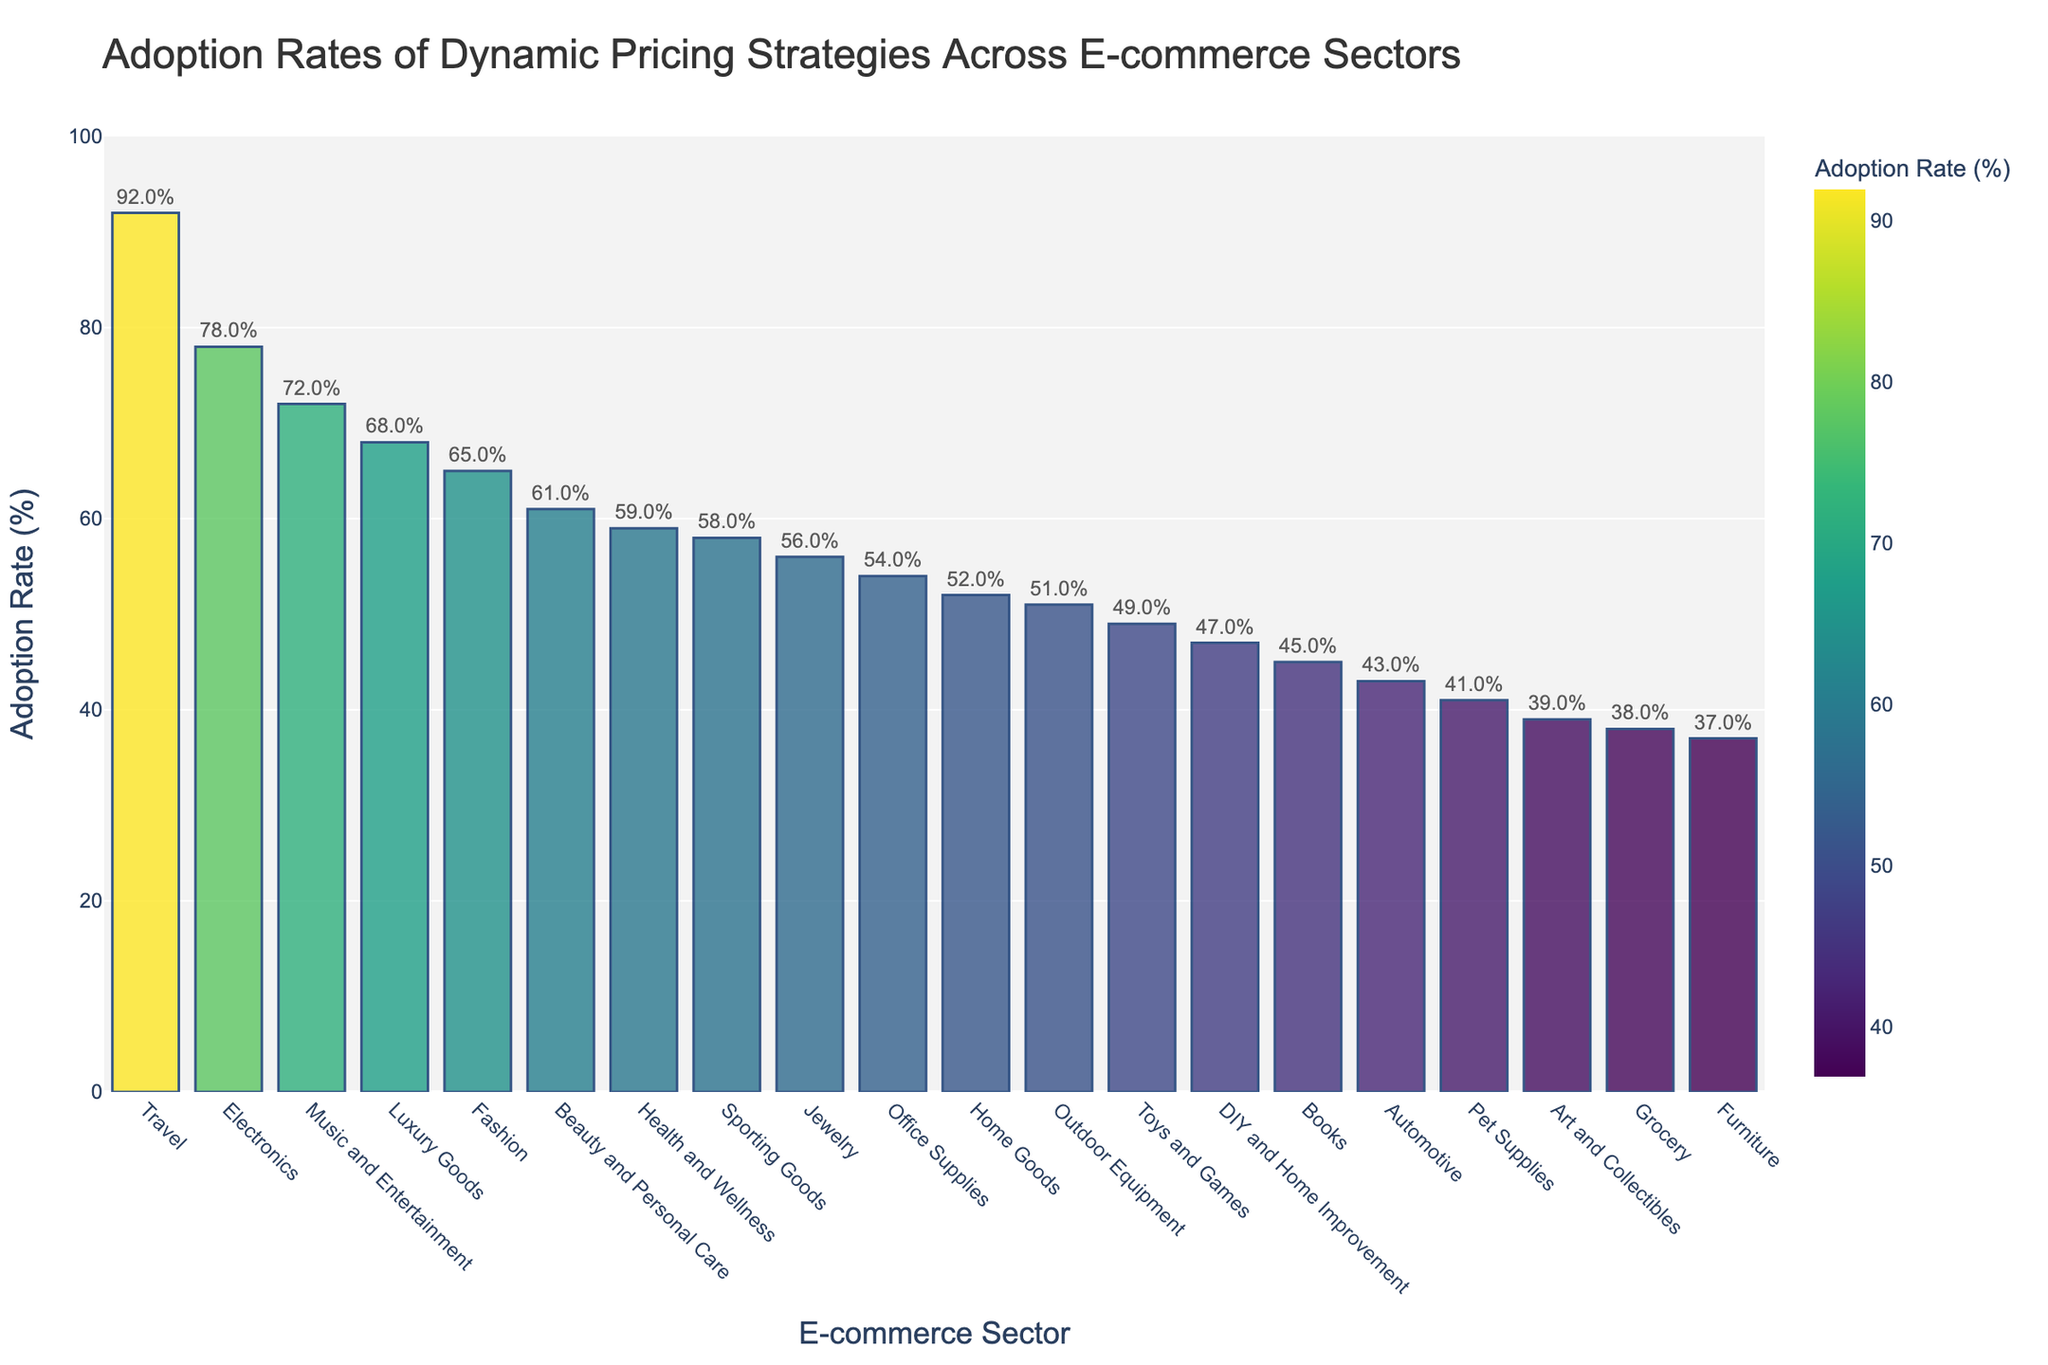Which sector has the highest adoption rate of dynamic pricing strategies? The bar representing "Travel" sector is the highest among all the bars in the chart.
Answer: Travel Which sector has the lowest adoption rate of dynamic pricing strategies? The bar representing "Furniture" sector is the lowest among all the bars in the chart.
Answer: Furniture What is the adoption rate difference between the Electronics and Grocery sectors? The adoption rate for Electronics is 78% and for Grocery, it is 38%. The difference is 78% - 38% = 40%.
Answer: 40% How many sectors have an adoption rate of over 60%? Count the number of bars that exceed the 60% mark. These sectors are Electronics, Fashion, Travel, Music and Entertainment, Health and Wellness, and Luxury Goods. There are 6 sectors in total.
Answer: 6 Identify the median adoption rate among the sectors. Sort the adoption rates and find the middle value. The sorted rates are: 37, 38, 39, 41, 43, 45, 47, 49, 52, 54, 56, 58, 59, 61, 65, 68, 72, 78, 92. The median value is the 10th value in this ordered list, which is 54%.
Answer: 54% Is the adoption rate for Art and Collectibles higher or lower than that for Jewelry? The adoption rate for Art and Collectibles is 39%, while that for Jewelry is 56%. 39% is lower than 56%.
Answer: Lower What is the average adoption rate for the sectors with a rate above 50%? Sectors above 50% are: Electronics (78%), Fashion (65%), Travel (92%), Home Goods (52%), Music and Entertainment (72%), Luxury Goods (68%), Health and Wellness (59%), Beauty and Personal Care (61%), Sporting Goods (58%), Office Supplies (54%), Jewelry (56%). Their total sum is 715%. There are 11 such sectors, so the average is 715 / 11 ≈ 65%.
Answer: 65% Compare the adoption rates of Sporting Goods and Beauty and Personal Care sectors. Which one is higher and by how much? Sporting Goods has 58% and Beauty and Personal Care has 61%. 61% is higher than 58%. The difference is 61% - 58% = 3%.
Answer: Beauty and Personal Care by 3% Which sector shows a close adoption rate to the average adoption rate across all sectors? Summing all adoption rates: 78 + 65 + 92 + 52 + 38 + 45 + 58 + 61 + 49 + 43 + 37 + 56 + 41 + 54 + 72 + 59 + 68 + 51 + 39 + 47 = 1066%. There are 20 sectors, average is 1066 / 20 = 53.3%. Home Goods (52%) and Office Supplies (54%) are closest to this average.
Answer: Home Goods and Office Supplies What's the combined adoption rate of the three lowest sectors? The lowest sectors are Furniture (37%), Grocery (38%), and Art and Collectibles (39%). Combined, the sum is 37 + 38 + 39 = 114%.
Answer: 114% 